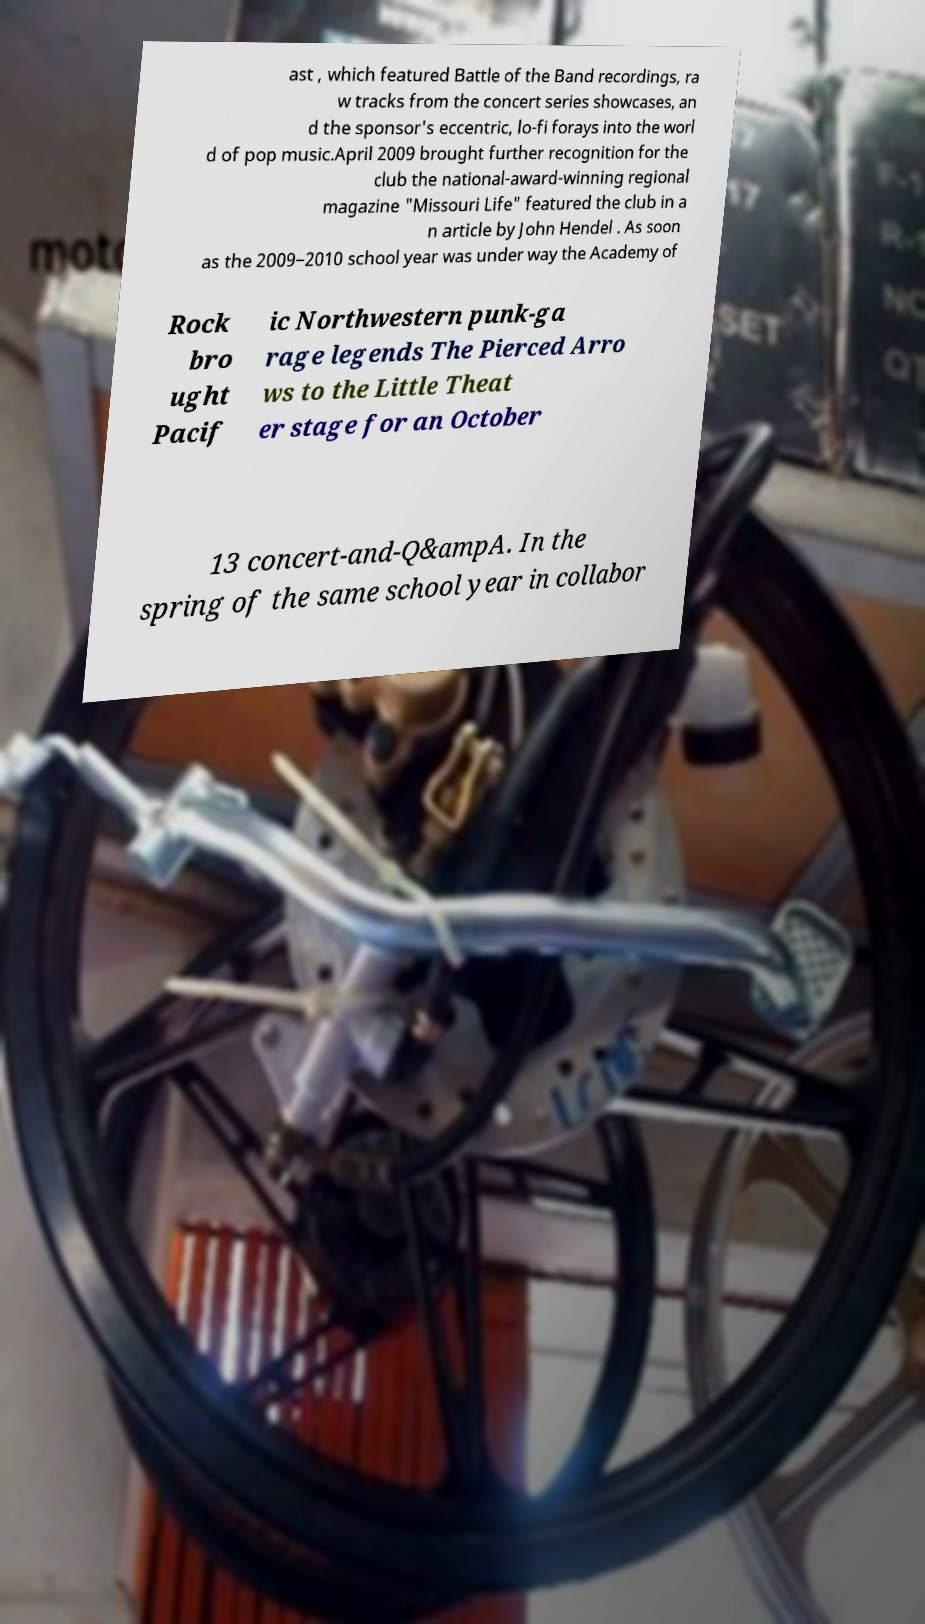Please read and relay the text visible in this image. What does it say? ast , which featured Battle of the Band recordings, ra w tracks from the concert series showcases, an d the sponsor's eccentric, lo-fi forays into the worl d of pop music.April 2009 brought further recognition for the club the national-award-winning regional magazine "Missouri Life" featured the club in a n article by John Hendel . As soon as the 2009–2010 school year was under way the Academy of Rock bro ught Pacif ic Northwestern punk-ga rage legends The Pierced Arro ws to the Little Theat er stage for an October 13 concert-and-Q&ampA. In the spring of the same school year in collabor 